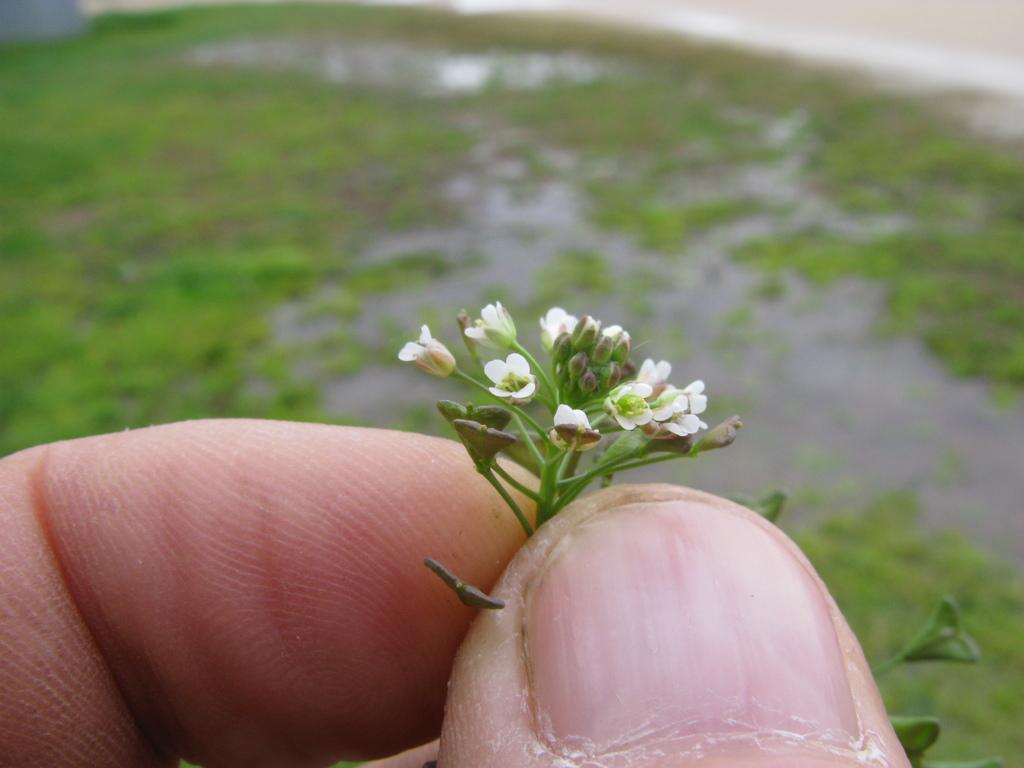What is the person in the image holding? The person is holding flowers in the image. Can you describe the color of the flowers? The flowers are white. What type of natural environment is visible in the image? There is grass visible in the image. Is there any water visible in the image? Yes, there is water visible in the image, but it is blurry. Can you hear the rat whistling in the image? There is no rat or whistling present in the image. 